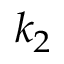Convert formula to latex. <formula><loc_0><loc_0><loc_500><loc_500>k _ { 2 }</formula> 